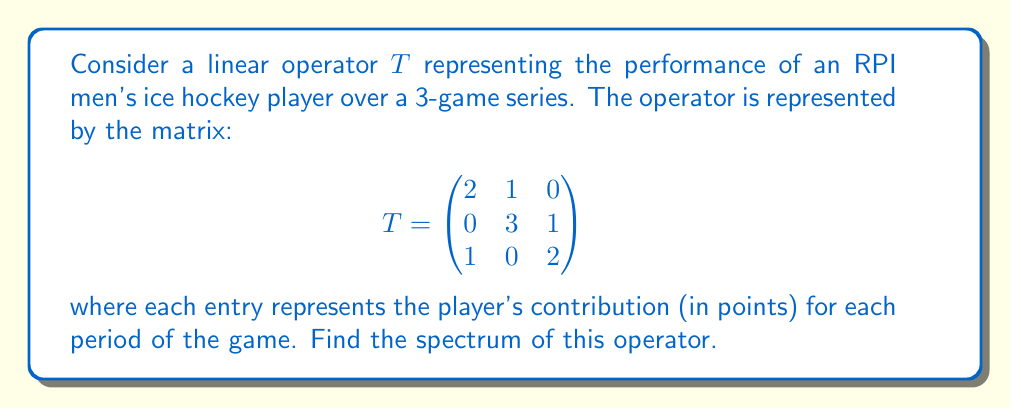Can you solve this math problem? To find the spectrum of the linear operator $T$, we need to find its eigenvalues.

Step 1: Set up the characteristic equation
$$\det(T - \lambda I) = 0$$

Step 2: Expand the determinant
$$\begin{vmatrix}
2-\lambda & 1 & 0 \\
0 & 3-\lambda & 1 \\
1 & 0 & 2-\lambda
\end{vmatrix} = 0$$

Step 3: Calculate the determinant
$$(2-\lambda)(3-\lambda)(2-\lambda) - (2-\lambda) - 1 = 0$$

Step 4: Simplify the equation
$$(2-\lambda)^2(3-\lambda) - (2-\lambda) - 1 = 0$$
$$(4-4\lambda+\lambda^2)(3-\lambda) - (2-\lambda) - 1 = 0$$
$$12-12\lambda+3\lambda^2-4\lambda+4\lambda^2-\lambda^3 - 2 + \lambda - 1 = 0$$

Step 5: Rearrange to standard form
$$-\lambda^3 + 7\lambda^2 - 15\lambda + 9 = 0$$

Step 6: Factor the equation
$$-(\lambda - 1)(\lambda - 3)(\lambda - 3) = 0$$

Step 7: Solve for $\lambda$
$$\lambda = 1 \text{ or } \lambda = 3$$

The eigenvalues are 1 (with algebraic multiplicity 1) and 3 (with algebraic multiplicity 2).

Therefore, the spectrum of $T$ is the set of these eigenvalues.
Answer: $\{1, 3\}$ 